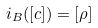<formula> <loc_0><loc_0><loc_500><loc_500>i _ { B } ( [ c ] ) = [ \rho ]</formula> 